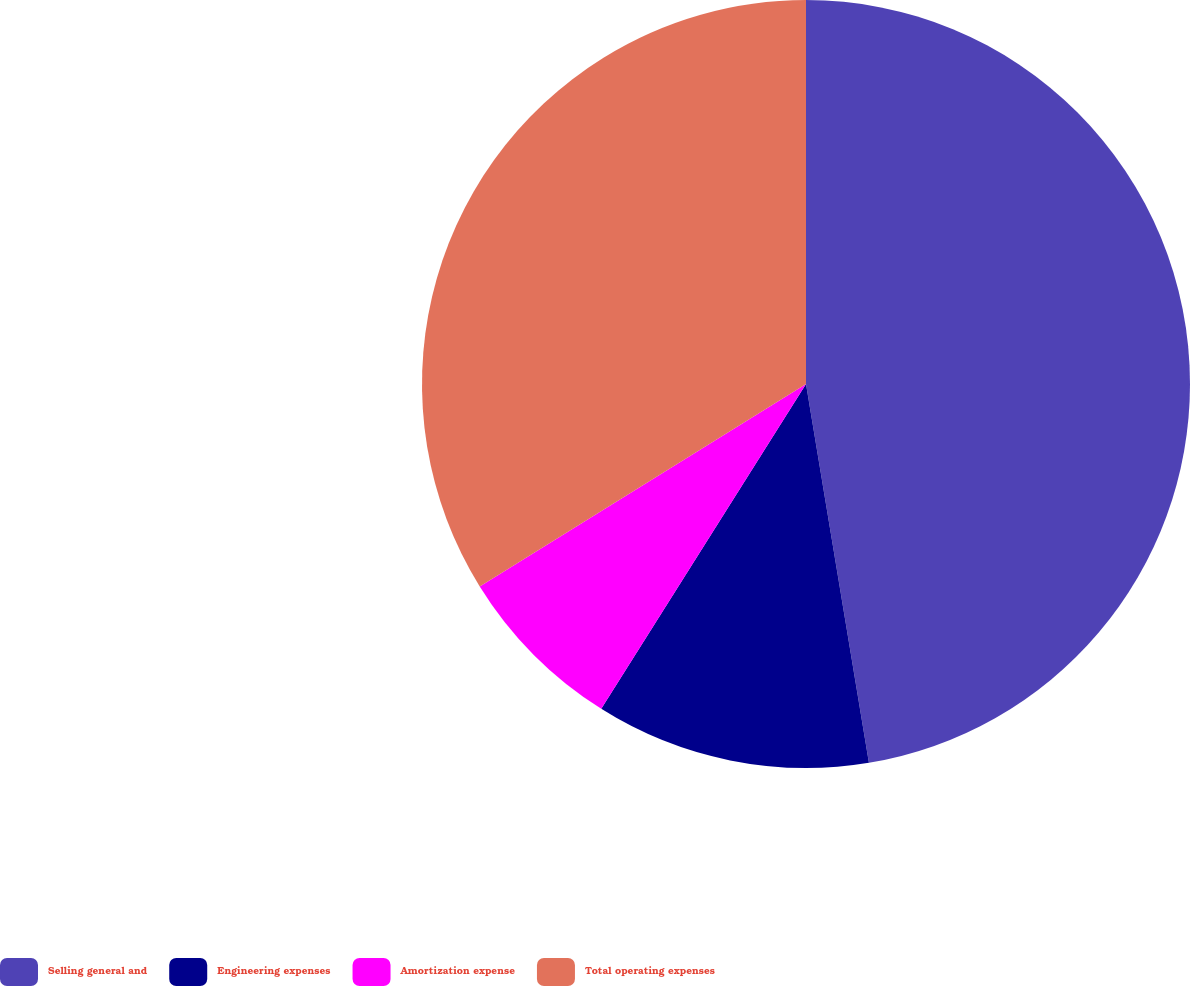Convert chart. <chart><loc_0><loc_0><loc_500><loc_500><pie_chart><fcel>Selling general and<fcel>Engineering expenses<fcel>Amortization expense<fcel>Total operating expenses<nl><fcel>47.38%<fcel>11.57%<fcel>7.21%<fcel>33.84%<nl></chart> 